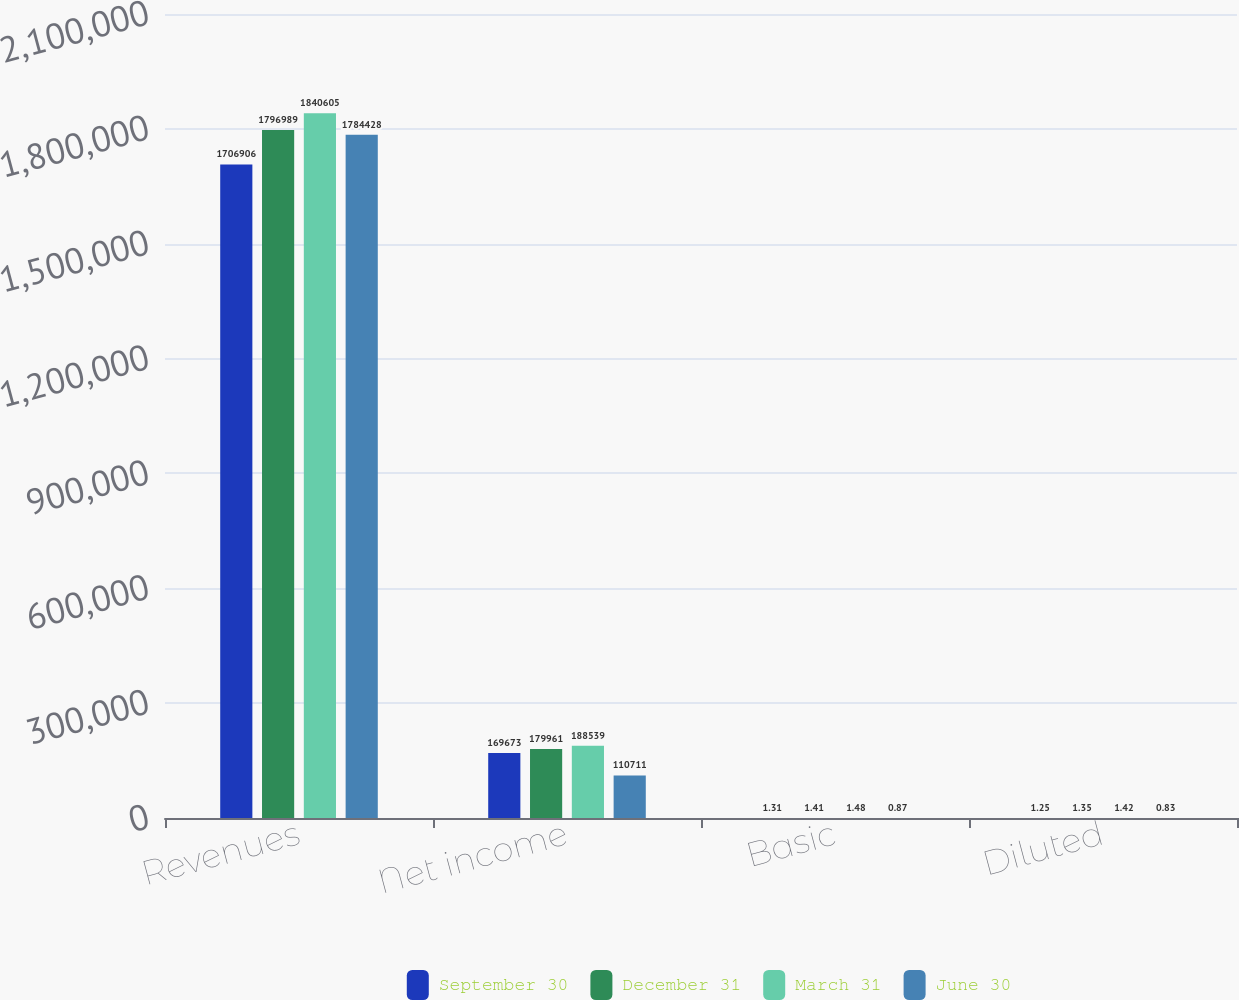<chart> <loc_0><loc_0><loc_500><loc_500><stacked_bar_chart><ecel><fcel>Revenues<fcel>Net income<fcel>Basic<fcel>Diluted<nl><fcel>September 30<fcel>1.70691e+06<fcel>169673<fcel>1.31<fcel>1.25<nl><fcel>December 31<fcel>1.79699e+06<fcel>179961<fcel>1.41<fcel>1.35<nl><fcel>March 31<fcel>1.8406e+06<fcel>188539<fcel>1.48<fcel>1.42<nl><fcel>June 30<fcel>1.78443e+06<fcel>110711<fcel>0.87<fcel>0.83<nl></chart> 